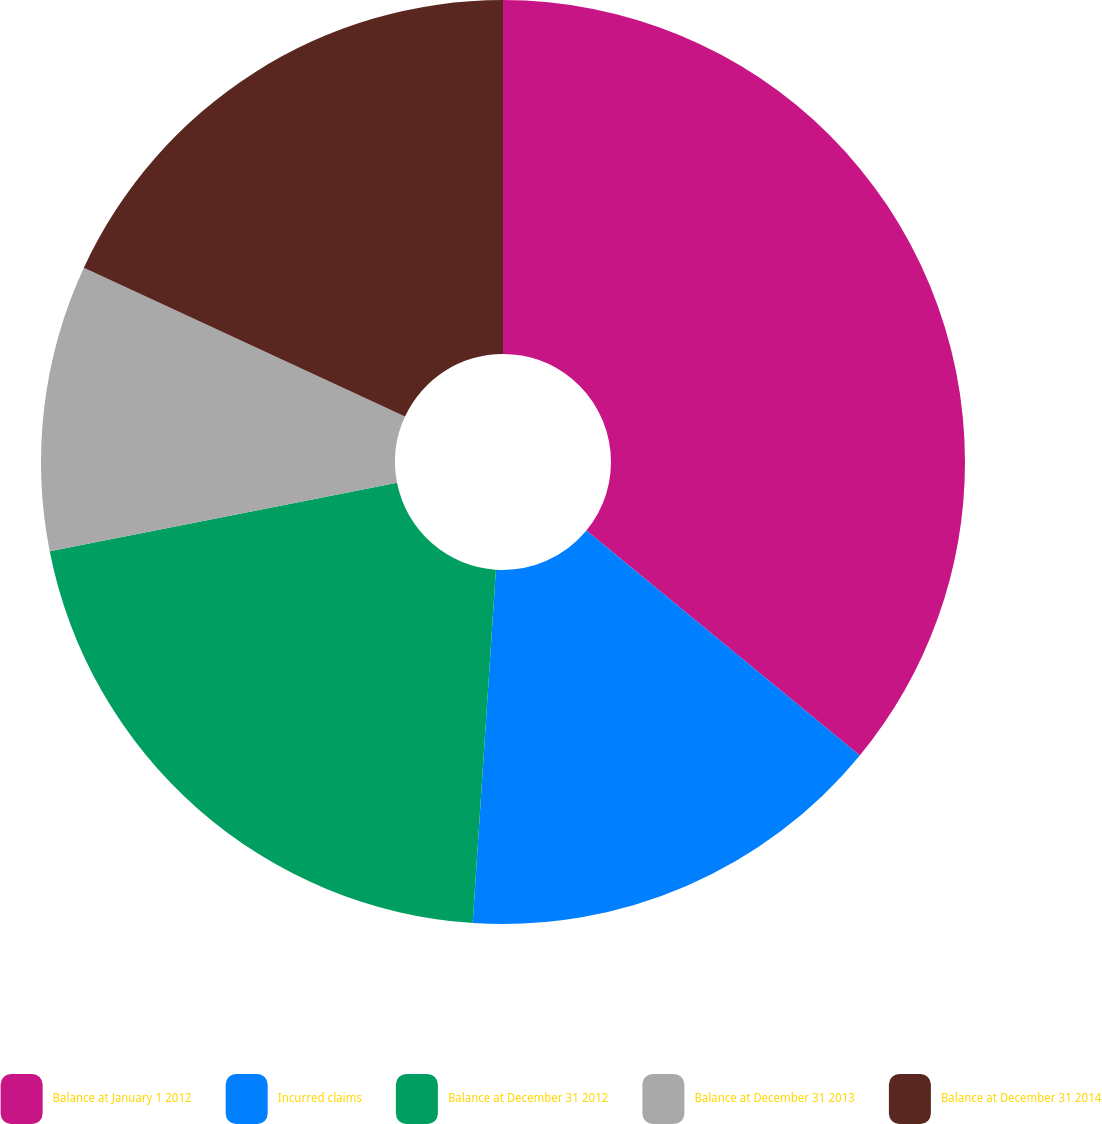Convert chart. <chart><loc_0><loc_0><loc_500><loc_500><pie_chart><fcel>Balance at January 1 2012<fcel>Incurred claims<fcel>Balance at December 31 2012<fcel>Balance at December 31 2013<fcel>Balance at December 31 2014<nl><fcel>35.95%<fcel>15.09%<fcel>20.86%<fcel>10.0%<fcel>18.09%<nl></chart> 